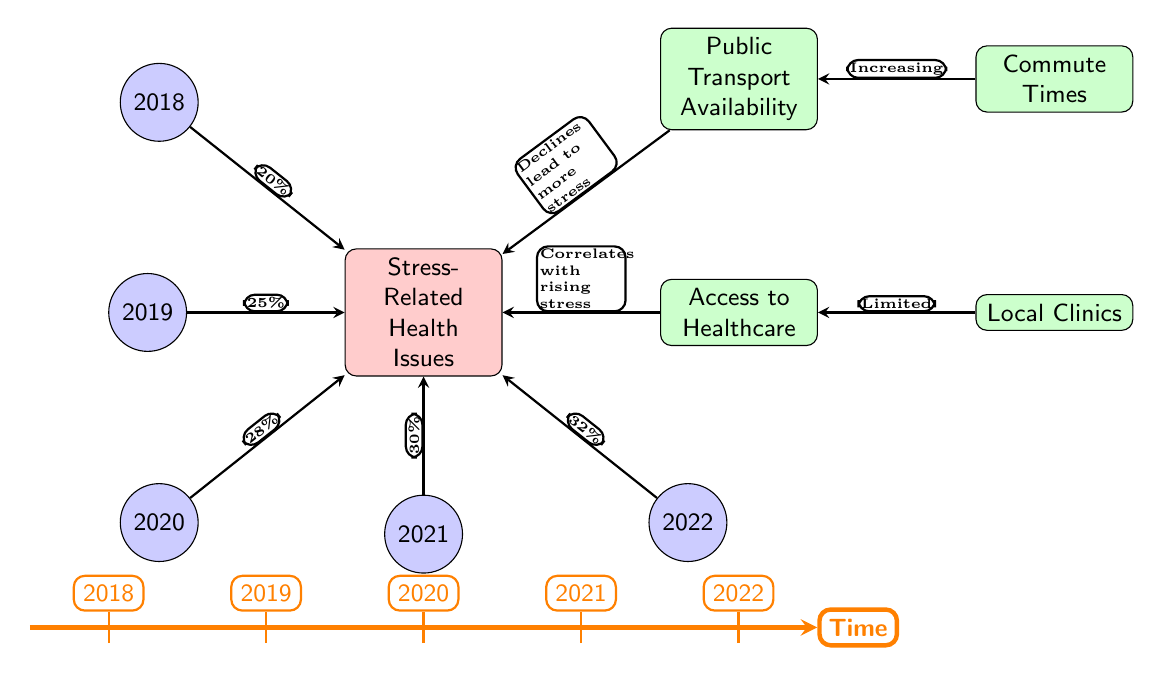What is the percentage of stress-related health issues in 2020? The diagram indicates that in 2020, the percentage of stress-related health issues is represented by an arrow coming from the 2020 node pointing to the stress node, showing a value of 28%.
Answer: 28% What year reflects the highest percentage of stress-related health issues? The arrows for 2018, 2019, 2020, 2021, and 2022 point to the stress node with increasing values. The highest percentage is indicated by the arrow from the 2022 node, which shows 32%.
Answer: 32% How does the availability of public transport relate to stress levels? The diagram shows an arrow from the Public Transport Availability node to the Stress-Related Health Issues node, indicating that declines in public transport availability lead to more stress.
Answer: Declines lead to more stress What percentage of stress-related health issues was recorded in 2019? The percentage of stress-related health issues in 2019 is shown by the arrow from the 2019 node to the stress node, which indicates a value of 25%.
Answer: 25% What is the trend of stress-related health issues from 2018 to 2022? The arrows connecting the years to the stress node show a gradual increase in stress-related health issues, rising from 20% in 2018 to 32% in 2022. This indicates a consistent upward trend over the years.
Answer: Increasing trend Which factor correlates with the rising stress levels? The arrow from the Access to Healthcare node points to the stress node, indicating that this factor correlates with rising stress levels, suggesting that as healthcare access decreases, stress levels increase.
Answer: Correlates with rising stress 